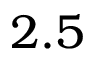<formula> <loc_0><loc_0><loc_500><loc_500>2 . 5</formula> 